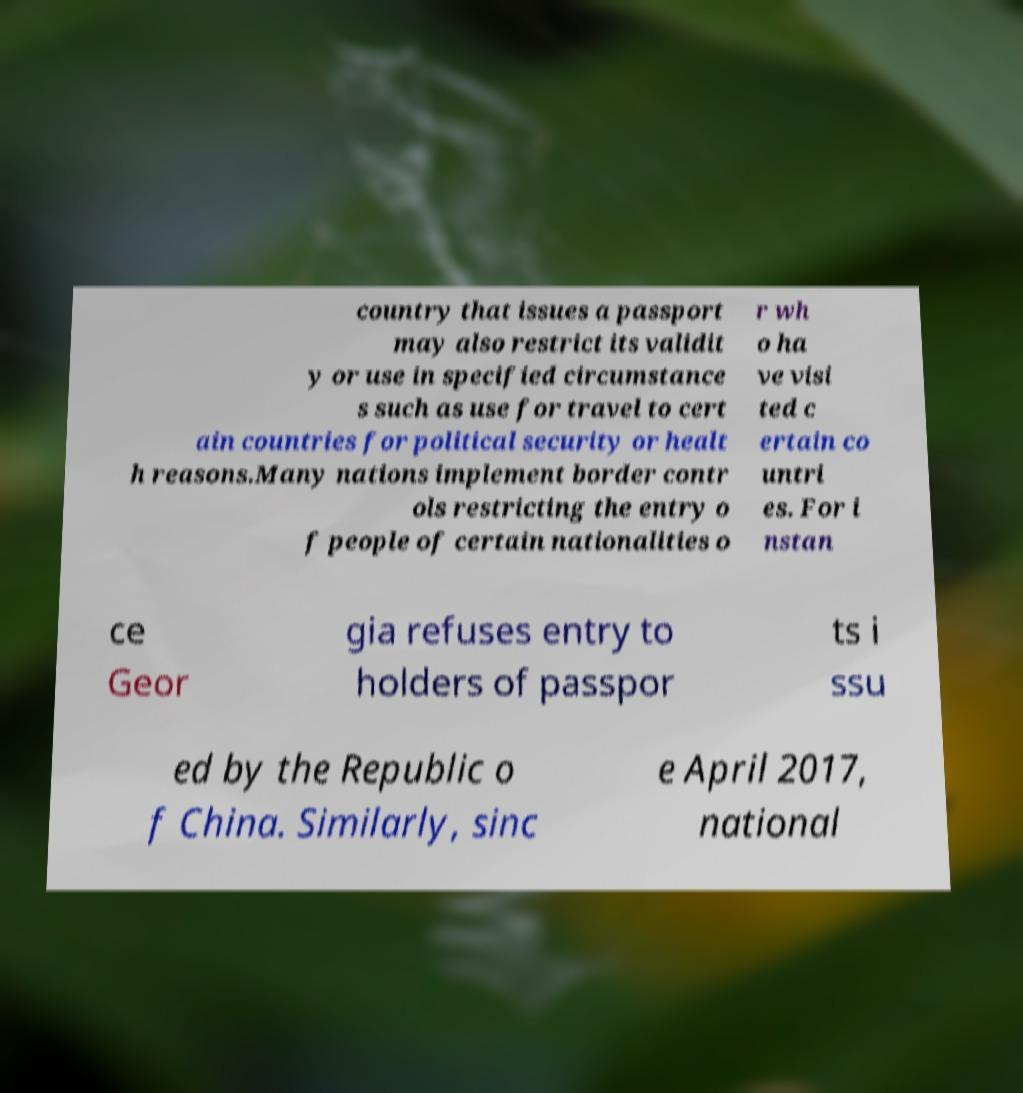Please read and relay the text visible in this image. What does it say? country that issues a passport may also restrict its validit y or use in specified circumstance s such as use for travel to cert ain countries for political security or healt h reasons.Many nations implement border contr ols restricting the entry o f people of certain nationalities o r wh o ha ve visi ted c ertain co untri es. For i nstan ce Geor gia refuses entry to holders of passpor ts i ssu ed by the Republic o f China. Similarly, sinc e April 2017, national 